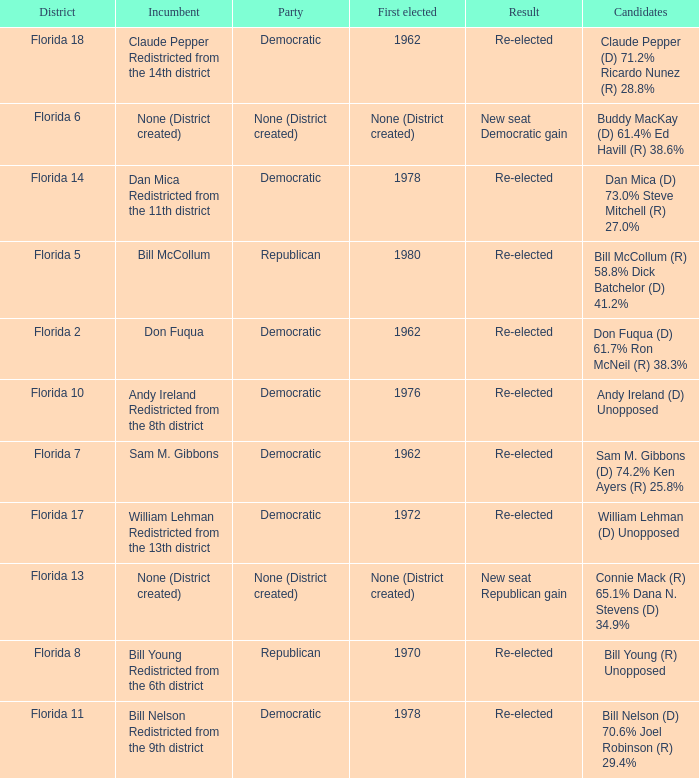What's the first elected with district being florida 7 1962.0. 